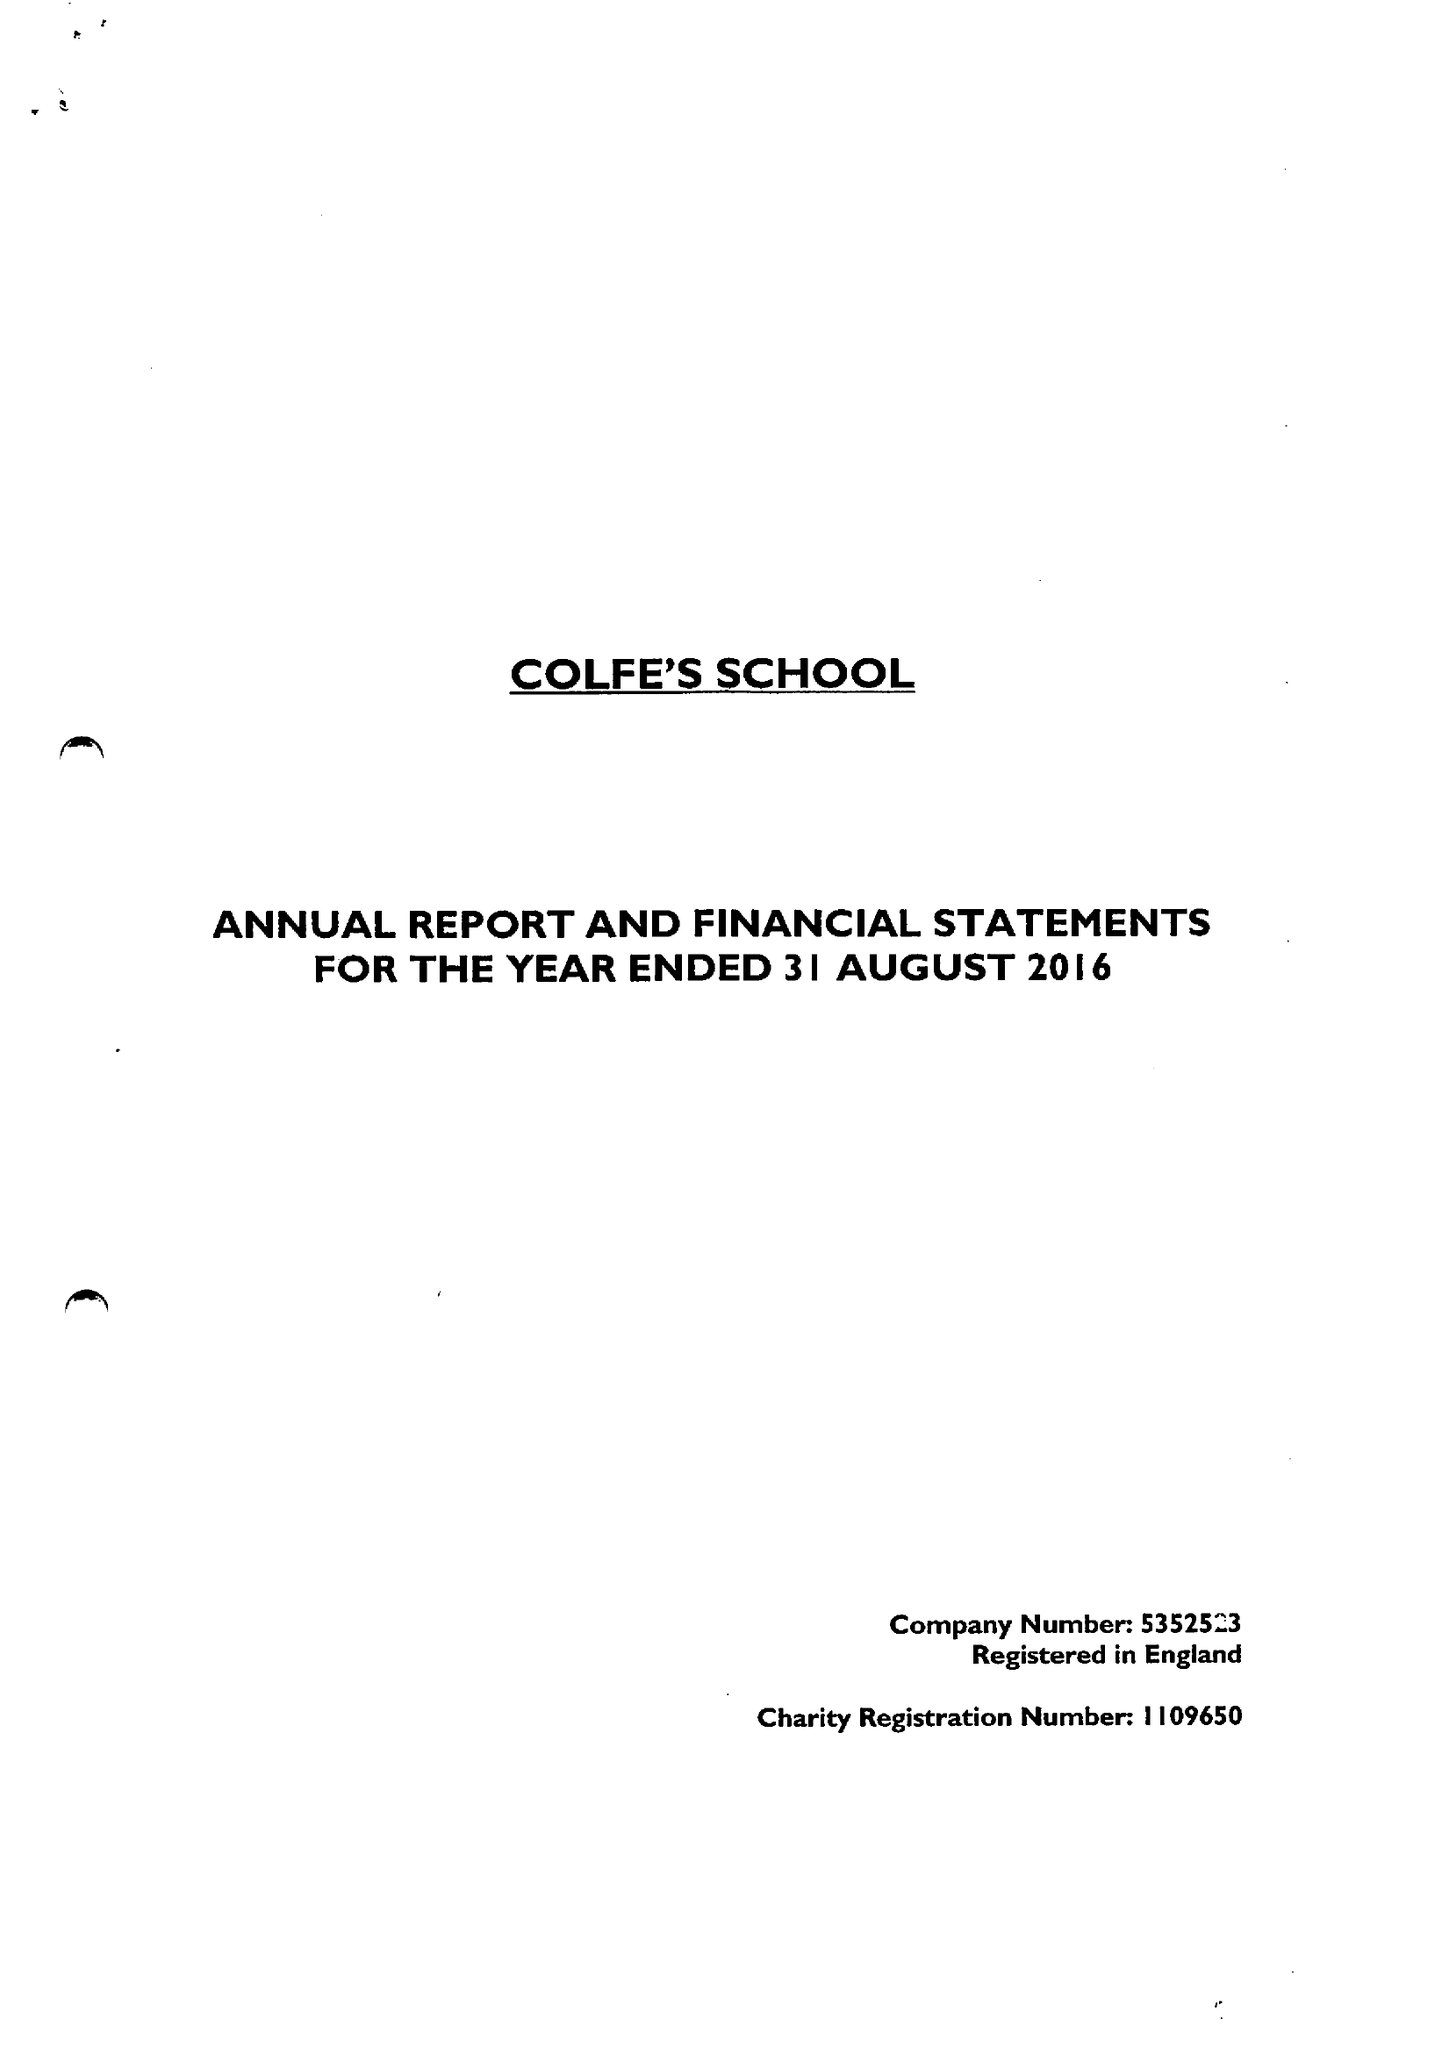What is the value for the report_date?
Answer the question using a single word or phrase. 2016-08-31 